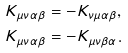Convert formula to latex. <formula><loc_0><loc_0><loc_500><loc_500>K _ { \mu \nu \alpha \beta } & = - K _ { \nu \mu \alpha \beta } , \\ K _ { \mu \nu \alpha \beta } & = - K _ { \mu \nu \beta \alpha } .</formula> 